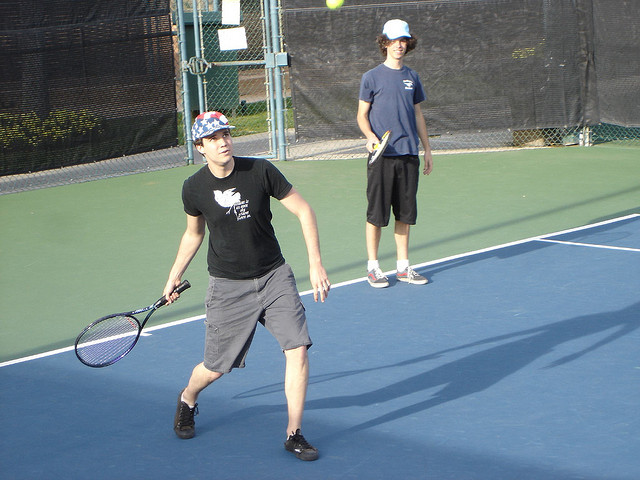<image>Are these guys winning the match? It's not certain whether these guys are winning the match or not. Are these guys winning the match? It is ambiguous whether these guys are winning the match. It is possible, but not certain. 